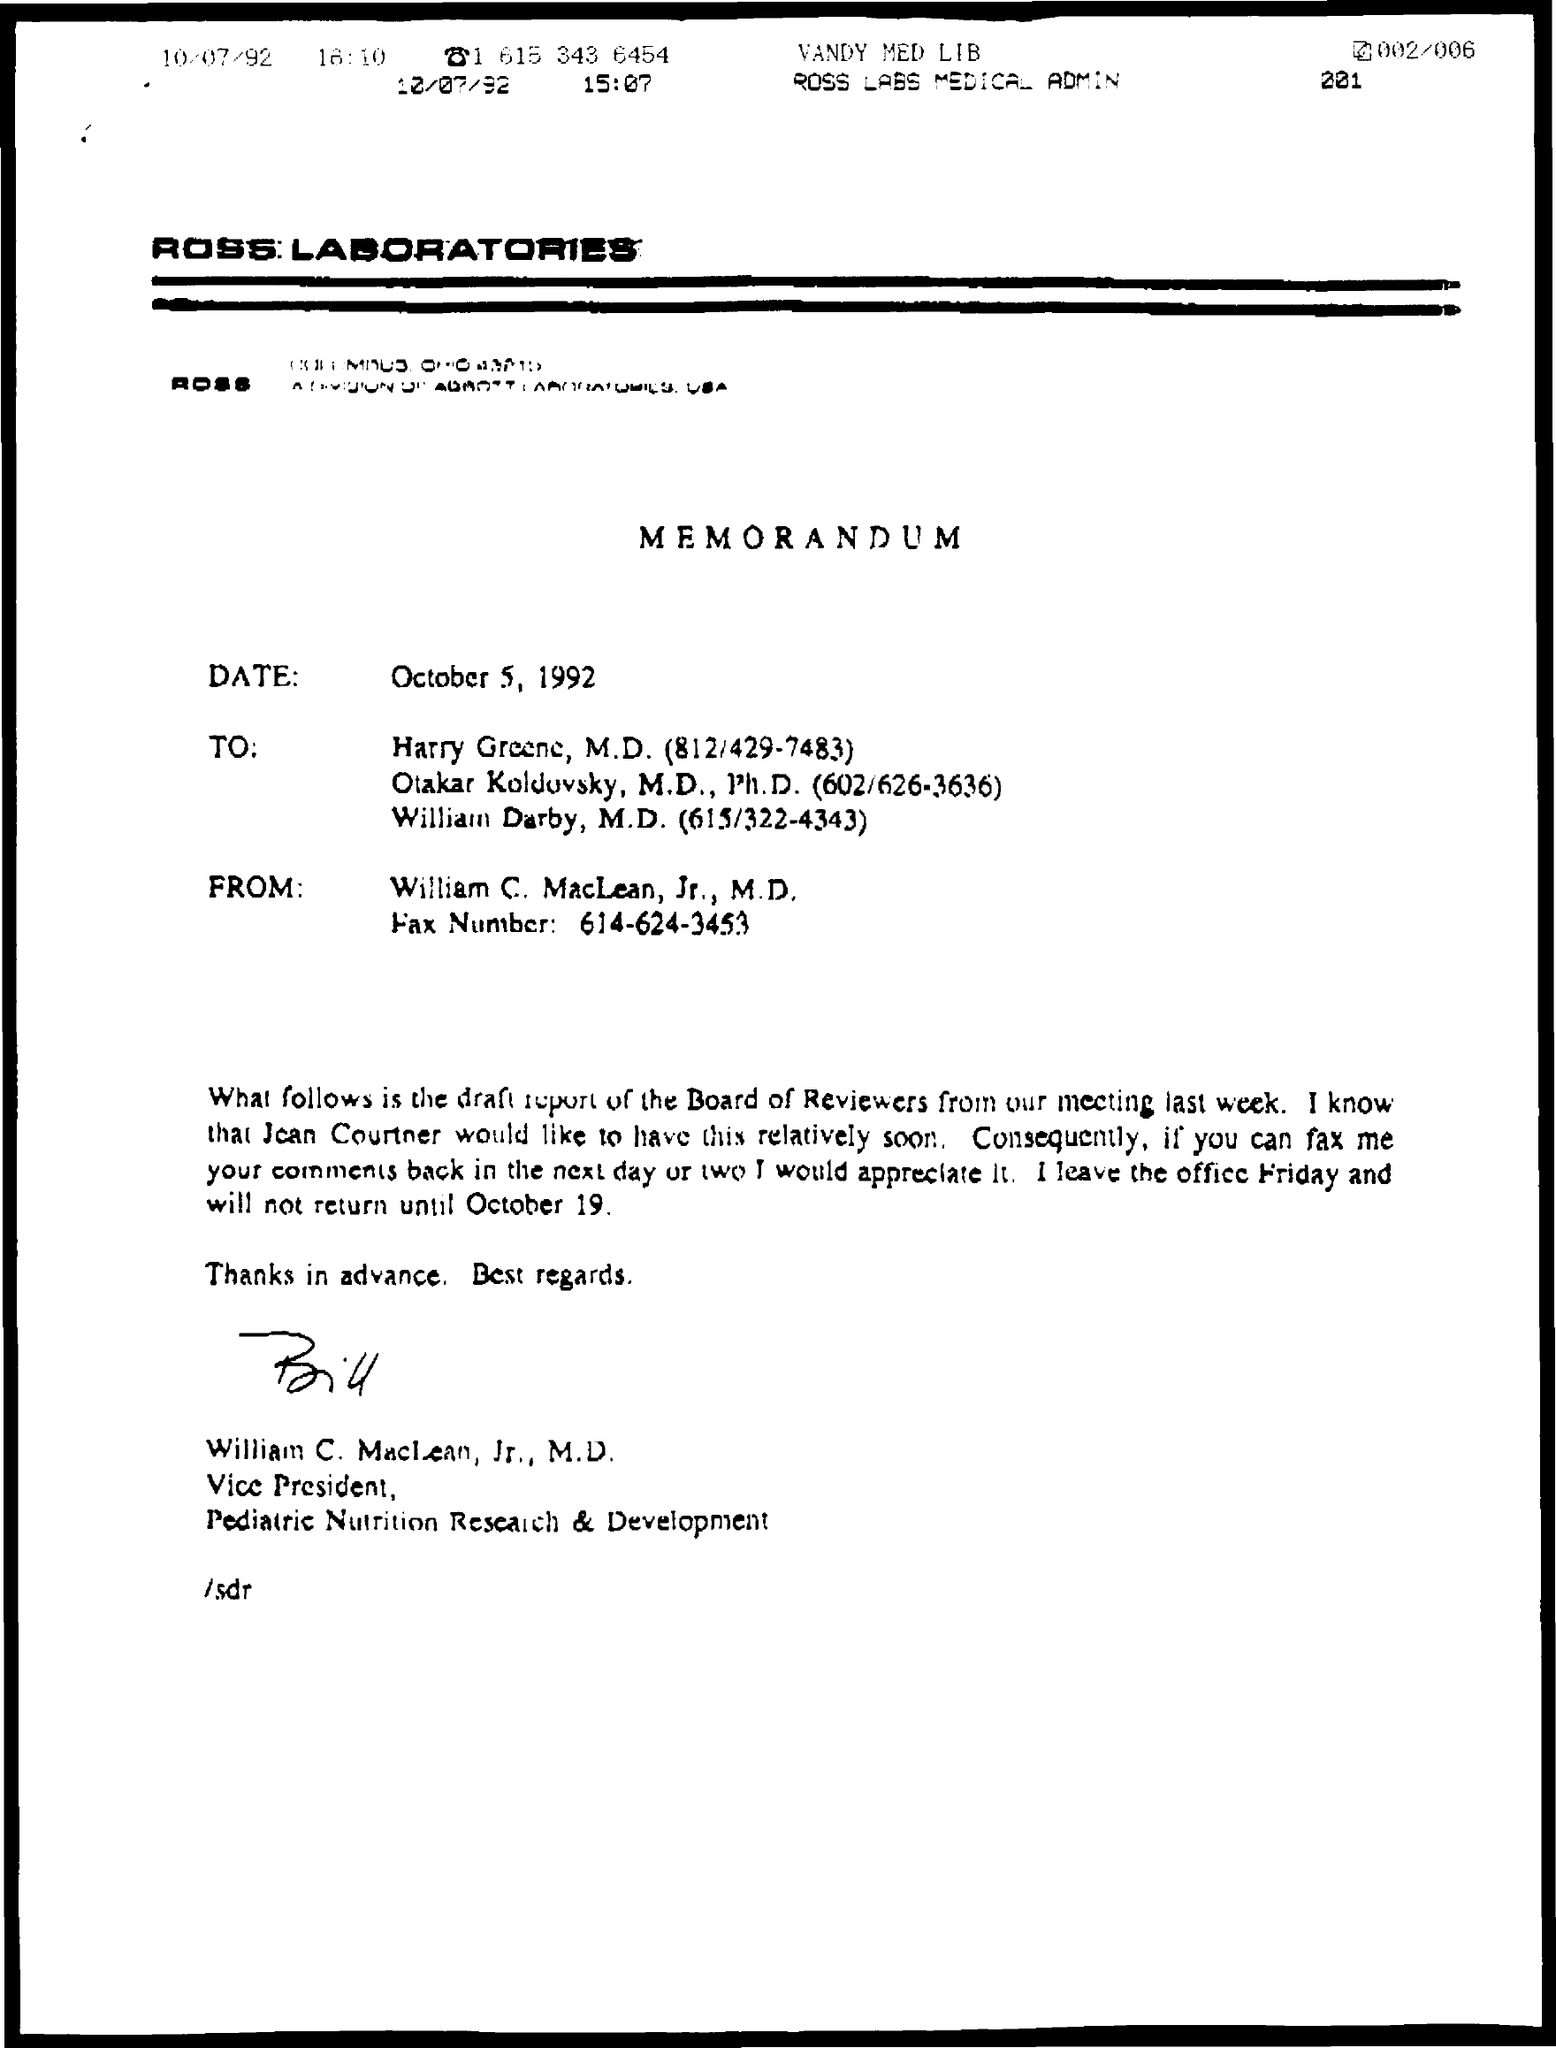Mention a couple of crucial points in this snapshot. The laboratory mentioned in the given page is named Ross Laboratories. William C. MacLean is designated as Vice President in the given letter. 